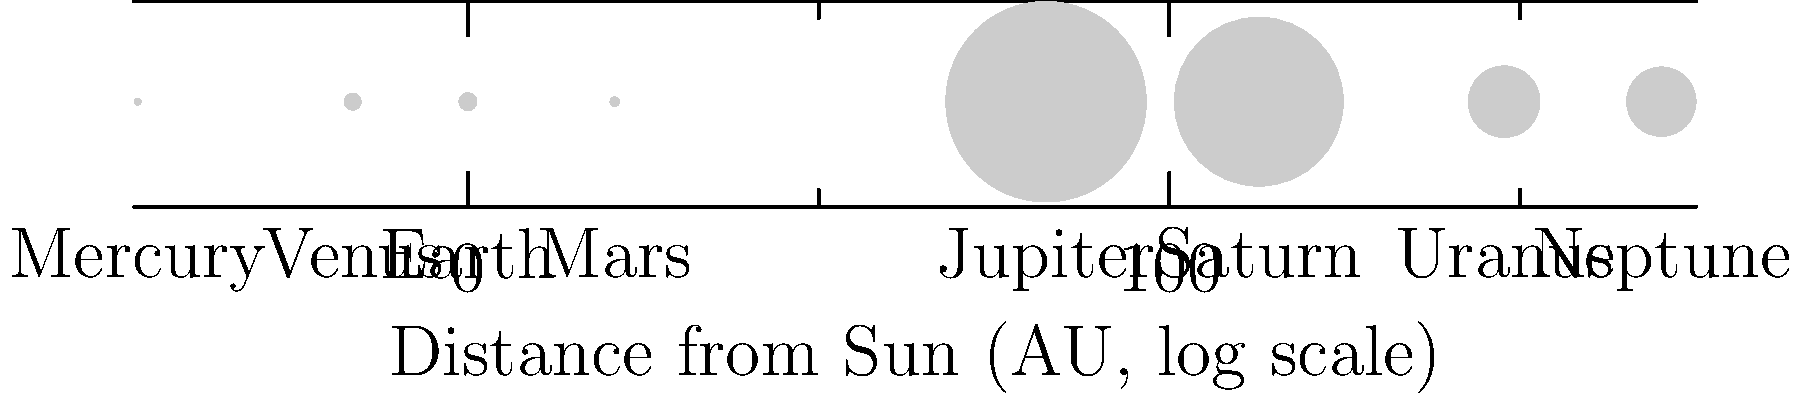As a public health officer concerned with potential future space colonization, you're reviewing astronomical data. The diagram shows the relative sizes and distances of planets in our Solar System. Which planet, represented by its size and position, would likely pose the greatest challenge for human habitation due to its extreme conditions, despite its similarity in size to Earth? To answer this question, we need to analyze the diagram and consider the implications for human habitation:

1. Identify Earth: Earth is the third planet from the Sun, with a relative size of 12.8 units.

2. Find similarly-sized planets: Venus (second from Sun) and Mars (fourth from Sun) are closest in size to Earth.

3. Consider distance from Sun:
   - Venus: Closer to Sun than Earth (0.72 AU vs. 1 AU)
   - Mars: Further from Sun than Earth (1.52 AU vs. 1 AU)

4. Evaluate habitability factors:
   - Venus: Proximity to Sun suggests extremely high temperatures
   - Mars: Greater distance suggests colder temperatures, but potentially more manageable

5. Consider atmospheric conditions (based on scientific knowledge):
   - Venus: Known for thick, toxic atmosphere and extreme greenhouse effect
   - Mars: Thin atmosphere, but less extreme than Venus

6. Conclusion: Venus poses the greatest challenge for human habitation due to its extreme heat and toxic atmosphere, despite its similarity in size to Earth.
Answer: Venus 